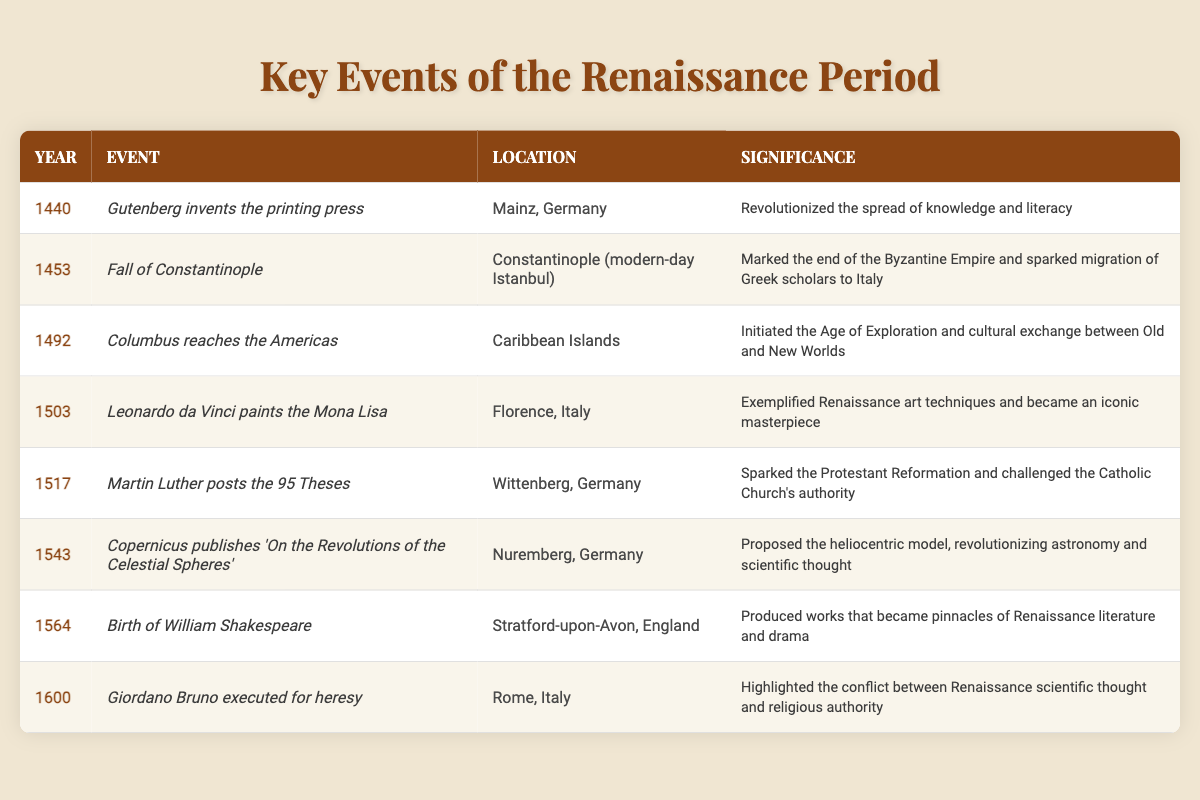What event occurred in 1492? According to the table, the event listed for the year 1492 is "Columbus reaches the Americas."
Answer: Columbus reaches the Americas Which event took place in Mainz, Germany? The table shows that in 1440, "Gutenberg invents the printing press" took place in Mainz, Germany.
Answer: Gutenberg invents the printing press What is the significance of the Fall of Constantinople? The significance stated in the table is that it marked the end of the Byzantine Empire and sparked migration of Greek scholars to Italy.
Answer: End of the Byzantine Empire; migration of Greek scholars How many years apart are the events of the printing press and the 95 Theses? The printing press was invented in 1440, and the 95 Theses were posted in 1517. The difference is 1517 - 1440 = 77 years.
Answer: 77 years Did Leonardo da Vinci paint the Mona Lisa before or after 1500? The table indicates that the Mona Lisa was painted in 1503, which is after 1500.
Answer: After What was the location of the event when Copernicus published his work? The table specifies that Copernicus published 'On the Revolutions of the Celestial Spheres' in Nuremberg, Germany.
Answer: Nuremberg, Germany What was the first significant event listed in the table? The first significant event in the table is "Gutenberg invents the printing press" in 1440.
Answer: Gutenberg invents the printing press Which event indicates a major change in religious authority? The event "Martin Luther posts the 95 Theses" in 1517 corresponds to a significant change in religious authority, as it sparked the Protestant Reformation.
Answer: Martin Luther posts the 95 Theses How many significant events listed occurred in the 16th century? The events from the 16th century in the table include: "Martin Luther posts the 95 Theses" (1517), "Copernicus publishes 'On the Revolutions of the Celestial Spheres'" (1543), and "Giordano Bruno executed for heresy" (1600), making it a total of 3 events.
Answer: 3 events Which event is associated with the Age of Exploration? The table mentions that "Columbus reaches the Americas" in 1492 initiated the Age of Exploration, making it the event associated with this period.
Answer: Columbus reaches the Americas 